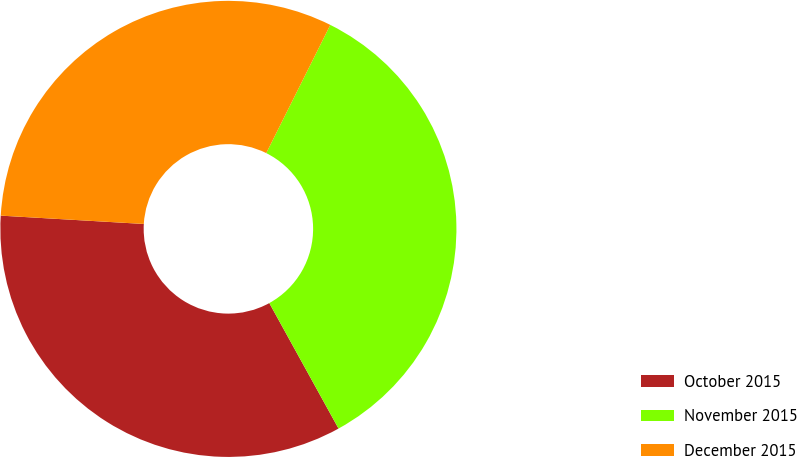Convert chart. <chart><loc_0><loc_0><loc_500><loc_500><pie_chart><fcel>October 2015<fcel>November 2015<fcel>December 2015<nl><fcel>33.95%<fcel>34.6%<fcel>31.45%<nl></chart> 